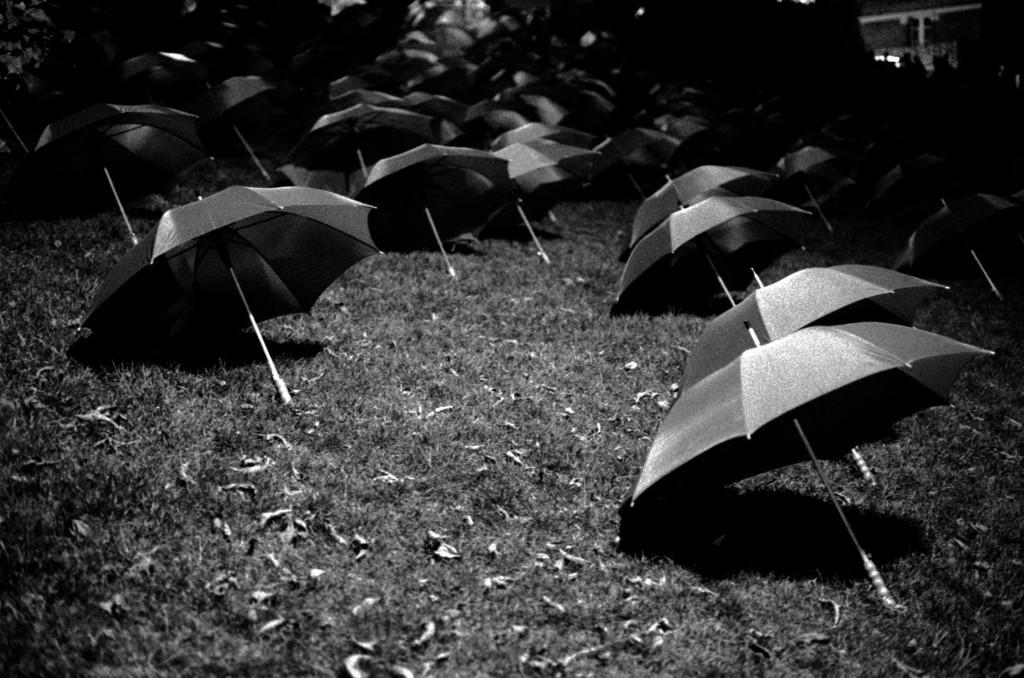How would you summarize this image in a sentence or two? This is a black and white image. There are many umbrellas on the grass. 